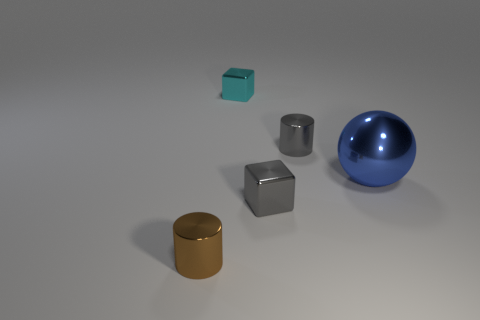Add 3 gray shiny objects. How many objects exist? 8 Subtract all gray cylinders. How many cylinders are left? 1 Subtract all cylinders. How many objects are left? 3 Subtract all small blue rubber cylinders. Subtract all large blue balls. How many objects are left? 4 Add 5 small metal cylinders. How many small metal cylinders are left? 7 Add 3 tiny blocks. How many tiny blocks exist? 5 Subtract 1 cyan cubes. How many objects are left? 4 Subtract 1 balls. How many balls are left? 0 Subtract all purple balls. Subtract all gray cubes. How many balls are left? 1 Subtract all green balls. How many purple cylinders are left? 0 